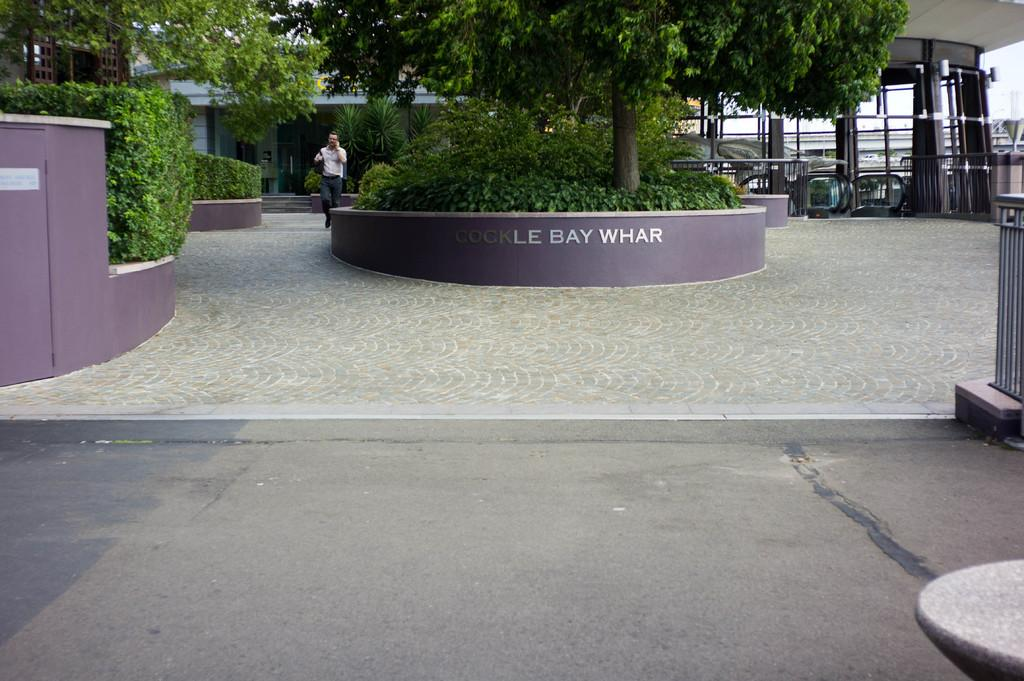What is in the foreground of the image? There is a road in the foreground of the image. What is in the background of the image? There is a path, trees, plants, a man walking, and a building in the background of the image. Can you describe the vegetation in the background of the image? Trees and plants are visible in the background of the image. What is the man in the background of the image doing? There is a man walking on the path in the background of the image. What type of comb is the man using to groom the plants in the image? There is no comb present in the image, and the man is not grooming any plants; he is walking on the path. What is the plot of the story being told in the image? There is no story being told in the image; it is a static representation of a scene. 